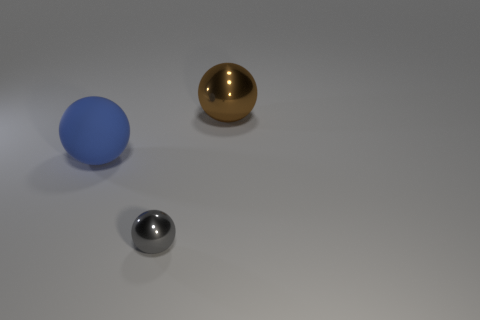Are there any other things that are made of the same material as the blue ball?
Offer a very short reply. No. Are there any other balls of the same color as the small ball?
Your answer should be very brief. No. What shape is the object that is the same size as the blue sphere?
Ensure brevity in your answer.  Sphere. What number of green objects are tiny balls or large balls?
Give a very brief answer. 0. What number of brown things are the same size as the gray shiny sphere?
Provide a short and direct response. 0. How many things are either matte cylinders or objects that are on the right side of the large blue thing?
Make the answer very short. 2. Is the size of the metal object right of the small shiny sphere the same as the ball to the left of the tiny thing?
Provide a short and direct response. Yes. How many large blue rubber things have the same shape as the brown object?
Your response must be concise. 1. There is a big object that is made of the same material as the gray sphere; what shape is it?
Give a very brief answer. Sphere. What is the material of the big object on the right side of the metal thing that is in front of the big thing that is left of the brown metal thing?
Offer a very short reply. Metal. 